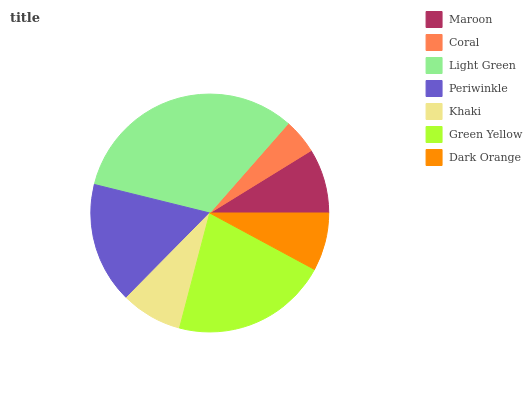Is Coral the minimum?
Answer yes or no. Yes. Is Light Green the maximum?
Answer yes or no. Yes. Is Light Green the minimum?
Answer yes or no. No. Is Coral the maximum?
Answer yes or no. No. Is Light Green greater than Coral?
Answer yes or no. Yes. Is Coral less than Light Green?
Answer yes or no. Yes. Is Coral greater than Light Green?
Answer yes or no. No. Is Light Green less than Coral?
Answer yes or no. No. Is Maroon the high median?
Answer yes or no. Yes. Is Maroon the low median?
Answer yes or no. Yes. Is Khaki the high median?
Answer yes or no. No. Is Khaki the low median?
Answer yes or no. No. 